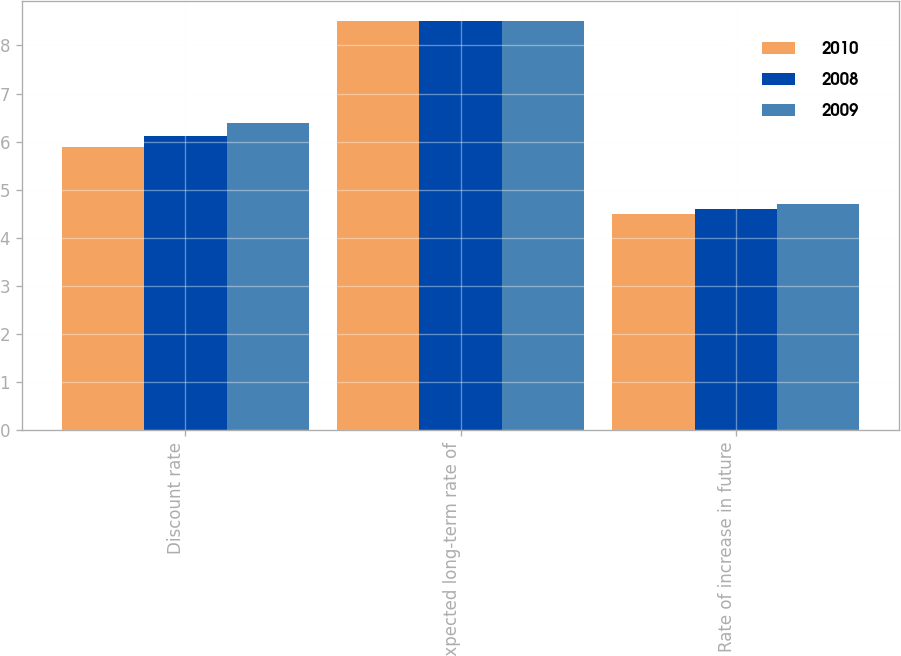Convert chart. <chart><loc_0><loc_0><loc_500><loc_500><stacked_bar_chart><ecel><fcel>Discount rate<fcel>Expected long-term rate of<fcel>Rate of increase in future<nl><fcel>2010<fcel>5.88<fcel>8.5<fcel>4.5<nl><fcel>2008<fcel>6.12<fcel>8.5<fcel>4.6<nl><fcel>2009<fcel>6.38<fcel>8.5<fcel>4.7<nl></chart> 